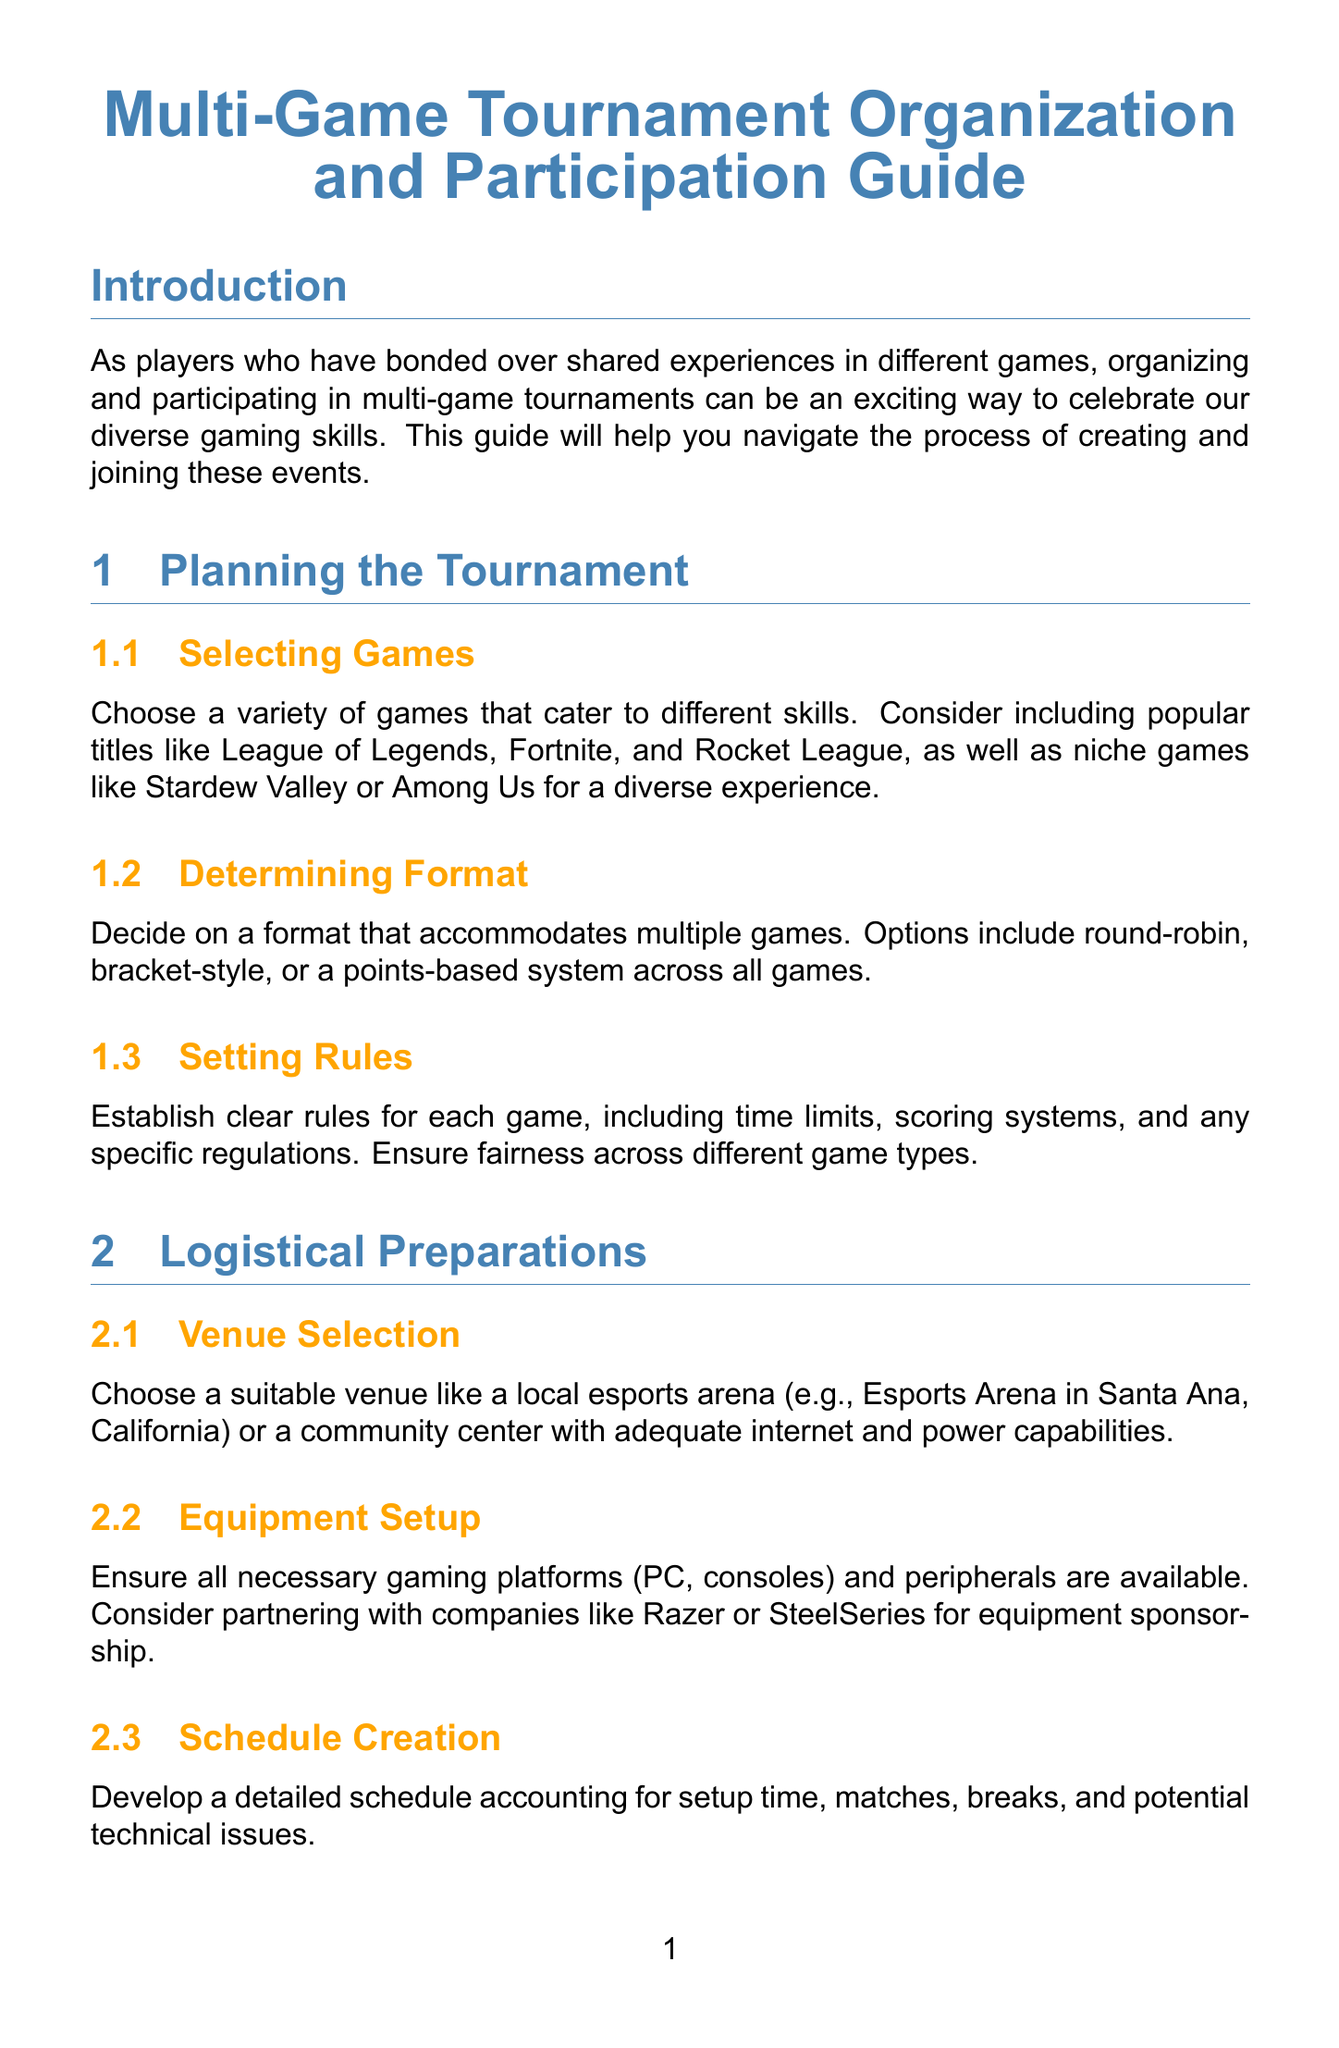What is the title of the document? The title is stated at the top of the document and summarizes its content.
Answer: Multi-Game Tournament Organization and Participation Guide What is one of the games suggested for a diverse experience? The document lists various games to consider for the tournament, including both popular and niche options.
Answer: Fortnite How should participants communicate prior to the tournament? The document suggests specific methods for keeping participants informed, indicating effective communication channels.
Answer: Discord server What software can be used for match management? The document mentions a particular tool designed for managing tournament matches and displaying results.
Answer: Toornament What is the purpose of feedback collection after the tournament? The document states the importance of gathering participant insights for future improvements.
Answer: Improving future events What type of structure can the tournament utilize? The document outlines different formats that can accommodate multiple games and competition styles.
Answer: Points-based system Where can you promote the tournament? The document provides examples of platforms suitable for marketing the event to reach potential participants.
Answer: Twitter What is an essential item participants should consider bringing? The document emphasizes the importance of specific equipment that participants might need during the tournament.
Answer: Universal controller 